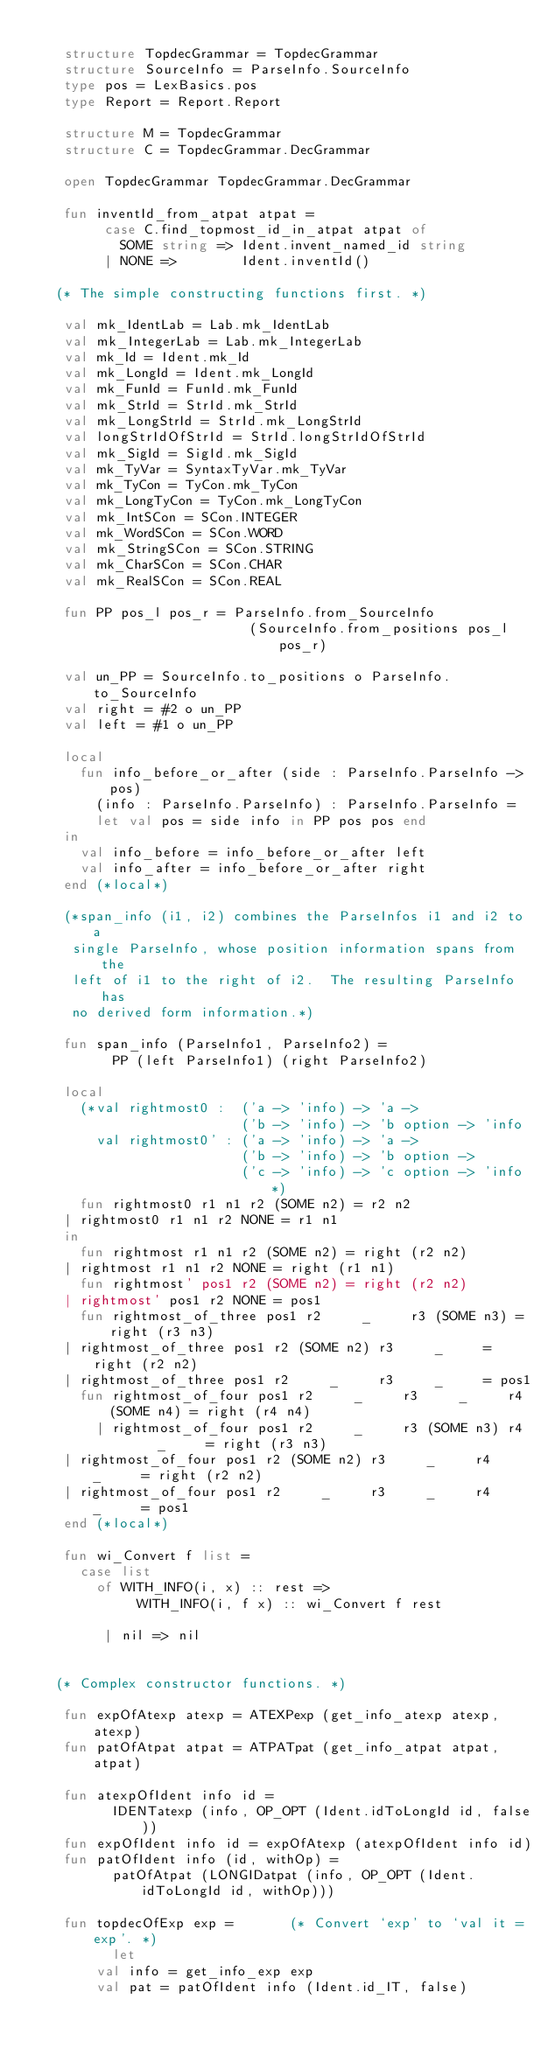Convert code to text. <code><loc_0><loc_0><loc_500><loc_500><_SML_>
    structure TopdecGrammar = TopdecGrammar
    structure SourceInfo = ParseInfo.SourceInfo
    type pos = LexBasics.pos
    type Report = Report.Report

    structure M = TopdecGrammar
    structure C = TopdecGrammar.DecGrammar

    open TopdecGrammar TopdecGrammar.DecGrammar

    fun inventId_from_atpat atpat = 
         case C.find_topmost_id_in_atpat atpat of
           SOME string => Ident.invent_named_id string
         | NONE =>        Ident.inventId()

   (* The simple constructing functions first. *)

    val mk_IdentLab = Lab.mk_IdentLab
    val mk_IntegerLab = Lab.mk_IntegerLab
    val mk_Id = Ident.mk_Id
    val mk_LongId = Ident.mk_LongId
    val mk_FunId = FunId.mk_FunId
    val mk_StrId = StrId.mk_StrId
    val mk_LongStrId = StrId.mk_LongStrId
    val longStrIdOfStrId = StrId.longStrIdOfStrId
    val mk_SigId = SigId.mk_SigId
    val mk_TyVar = SyntaxTyVar.mk_TyVar
    val mk_TyCon = TyCon.mk_TyCon
    val mk_LongTyCon = TyCon.mk_LongTyCon
    val mk_IntSCon = SCon.INTEGER
    val mk_WordSCon = SCon.WORD
    val mk_StringSCon = SCon.STRING
    val mk_CharSCon = SCon.CHAR
    val mk_RealSCon = SCon.REAL

    fun PP pos_l pos_r = ParseInfo.from_SourceInfo
                           (SourceInfo.from_positions pos_l pos_r)

    val un_PP = SourceInfo.to_positions o ParseInfo.to_SourceInfo
    val right = #2 o un_PP
    val left = #1 o un_PP

    local 
      fun info_before_or_after (side : ParseInfo.ParseInfo -> pos)
	    (info : ParseInfo.ParseInfo) : ParseInfo.ParseInfo =
	    let val pos = side info in PP pos pos end
    in
      val info_before = info_before_or_after left
      val info_after = info_before_or_after right
    end (*local*)

    (*span_info (i1, i2) combines the ParseInfos i1 and i2 to a
     single ParseInfo, whose position information spans from the
     left of i1 to the right of i2.  The resulting ParseInfo has
     no derived form information.*)

    fun span_info (ParseInfo1, ParseInfo2) =
          PP (left ParseInfo1) (right ParseInfo2)

    local
      (*val rightmost0 :  ('a -> 'info) -> 'a ->
                          ('b -> 'info) -> 'b option -> 'info
        val rightmost0' : ('a -> 'info) -> 'a ->
                          ('b -> 'info) -> 'b option ->
                          ('c -> 'info) -> 'c option -> 'info*)
      fun rightmost0 r1 n1 r2 (SOME n2) = r2 n2
	| rightmost0 r1 n1 r2 NONE = r1 n1
    in
      fun rightmost r1 n1 r2 (SOME n2) = right (r2 n2)
	| rightmost r1 n1 r2 NONE = right (r1 n1)
      fun rightmost' pos1 r2 (SOME n2) = right (r2 n2)
	| rightmost' pos1 r2 NONE = pos1
      fun rightmost_of_three pos1 r2     _     r3 (SOME n3) = right (r3 n3)
	| rightmost_of_three pos1 r2 (SOME n2) r3     _     = right (r2 n2)
	| rightmost_of_three pos1 r2     _     r3     _     = pos1
      fun rightmost_of_four pos1 r2     _     r3     _     r4 (SOME n4) = right (r4 n4)
        | rightmost_of_four pos1 r2     _     r3 (SOME n3) r4     _     = right (r3 n3)
	| rightmost_of_four pos1 r2 (SOME n2) r3     _     r4     _     = right (r2 n2)
	| rightmost_of_four pos1 r2     _     r3     _     r4     _     = pos1
    end (*local*)

    fun wi_Convert f list =
      case list
        of WITH_INFO(i, x) :: rest =>
             WITH_INFO(i, f x) :: wi_Convert f rest

         | nil => nil


   (* Complex constructor functions. *)

    fun expOfAtexp atexp = ATEXPexp (get_info_atexp atexp, atexp)
    fun patOfAtpat atpat = ATPATpat (get_info_atpat atpat, atpat)

    fun atexpOfIdent info id = 
          IDENTatexp (info, OP_OPT (Ident.idToLongId id, false))
    fun expOfIdent info id = expOfAtexp (atexpOfIdent info id)
    fun patOfIdent info (id, withOp) =
          patOfAtpat (LONGIDatpat (info, OP_OPT (Ident.idToLongId id, withOp)))

    fun topdecOfExp exp =       (* Convert `exp' to `val it = exp'. *)
          let
	    val info = get_info_exp exp
	    val pat = patOfIdent info (Ident.id_IT, false)</code> 